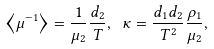Convert formula to latex. <formula><loc_0><loc_0><loc_500><loc_500>\left \langle \mu ^ { - 1 } \right \rangle = \frac { 1 } { \mu _ { 2 } } \frac { d _ { 2 } } { T } , \ \kappa = \frac { d _ { 1 } d _ { 2 } } { T ^ { 2 } } \frac { \rho _ { 1 } } { \mu _ { 2 } } ,</formula> 